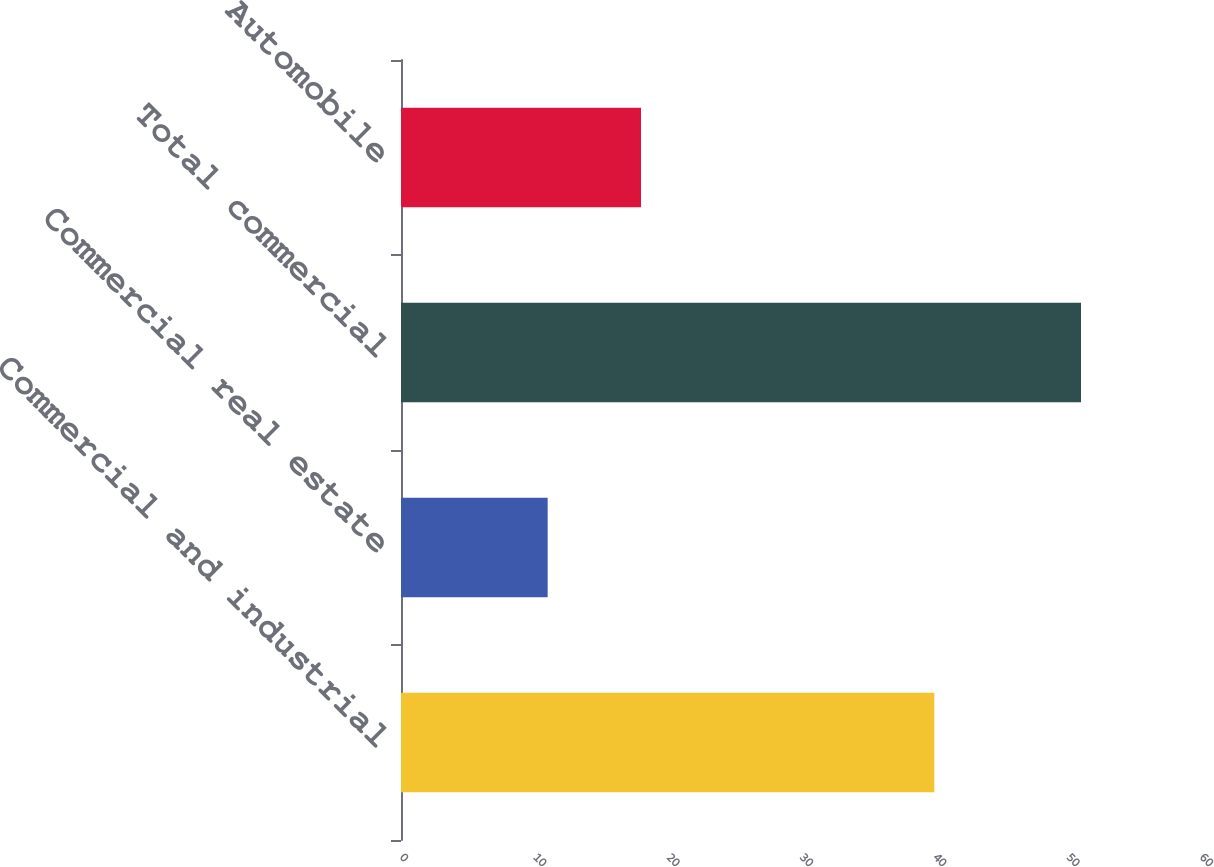<chart> <loc_0><loc_0><loc_500><loc_500><bar_chart><fcel>Commercial and industrial<fcel>Commercial real estate<fcel>Total commercial<fcel>Automobile<nl><fcel>40<fcel>11<fcel>51<fcel>18<nl></chart> 